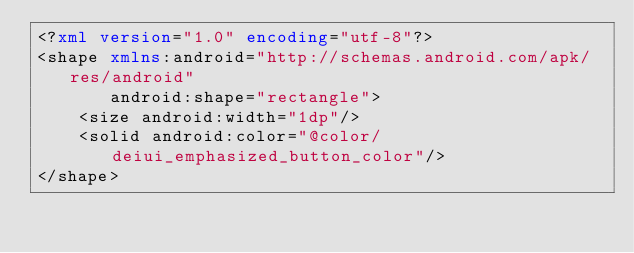Convert code to text. <code><loc_0><loc_0><loc_500><loc_500><_XML_><?xml version="1.0" encoding="utf-8"?>
<shape xmlns:android="http://schemas.android.com/apk/res/android"
       android:shape="rectangle">
    <size android:width="1dp"/>
    <solid android:color="@color/deiui_emphasized_button_color"/>
</shape></code> 